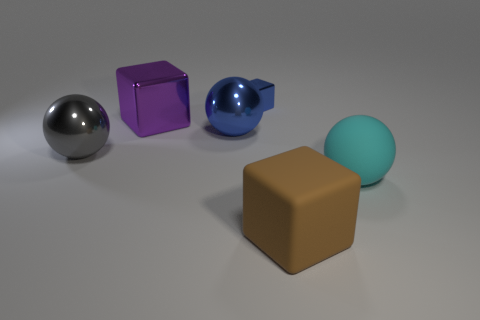There is a big cube that is behind the big gray shiny object; what material is it? metal 